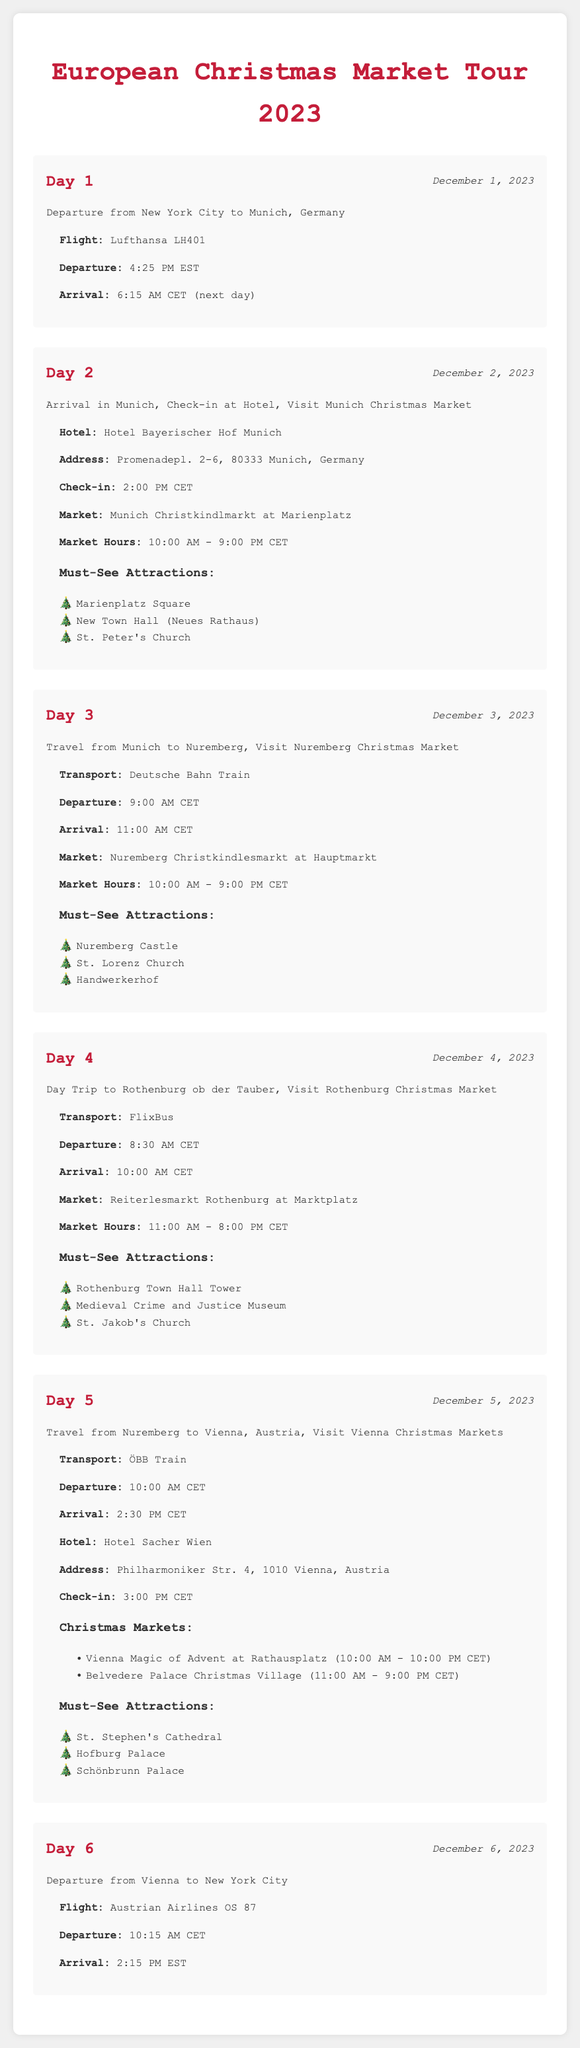What is the flight number for the departure from New York City to Munich? The flight number is listed under the flight details for Day 1, which is Lufthansa LH401.
Answer: Lufthansa LH401 When does the Munich Christmas Market open? The opening hours for the Munich Christmas Market are provided in the details for Day 2. It states that it opens at 10:00 AM CET.
Answer: 10:00 AM CET What is the market name at Hauptmarkt in Nuremberg? The document mentions the market name located at Hauptmarkt under Day 3, which is Nuremberg Christkindlesmarkt.
Answer: Nuremberg Christkindlesmarkt What time does the Rothenburg Christmas Market close? The closing time for the Rothenburg Christmas Market is mentioned in the details for Day 4. It closes at 8:00 PM CET.
Answer: 8:00 PM CET How long is the flight from Vienna to New York City? The flight duration is found by calculating the departure and arrival times listed under Day 6, which shows a 9-hour flight.
Answer: 9 hours What attractions are listed under must-see in Vienna? The must-see attractions for Vienna are listed under Day 5. They include St. Stephen's Cathedral, Hofburg Palace, and Schönbrunn Palace.
Answer: St. Stephen's Cathedral, Hofburg Palace, Schönbrunn Palace What is the check-in time at Hotel Bayerischer Hof Munich? The check-in time is specified in the details for Day 2, which states 2:00 PM CET.
Answer: 2:00 PM CET Which transport will be used to go from Munich to Vienna? The transport method is described in the details for Day 5 as ÖBB Train.
Answer: ÖBB Train What is the departure time for the train from Munich to Nuremberg? The departure time for the train can be found in the details of Day 3, stating it departs at 9:00 AM CET.
Answer: 9:00 AM CET 